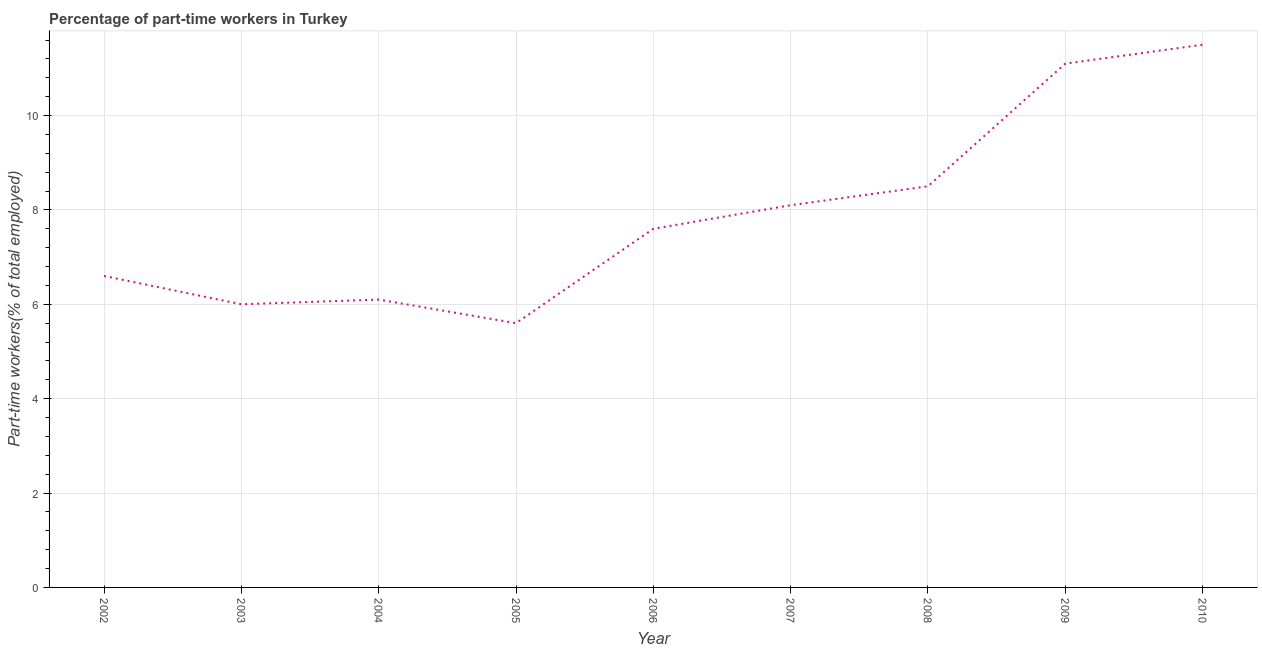What is the percentage of part-time workers in 2002?
Your response must be concise. 6.6. Across all years, what is the minimum percentage of part-time workers?
Offer a very short reply. 5.6. What is the sum of the percentage of part-time workers?
Keep it short and to the point. 71.1. What is the difference between the percentage of part-time workers in 2002 and 2006?
Provide a succinct answer. -1. What is the average percentage of part-time workers per year?
Offer a very short reply. 7.9. What is the median percentage of part-time workers?
Your answer should be compact. 7.6. In how many years, is the percentage of part-time workers greater than 3.2 %?
Your answer should be compact. 9. What is the ratio of the percentage of part-time workers in 2002 to that in 2004?
Provide a succinct answer. 1.08. Is the percentage of part-time workers in 2004 less than that in 2007?
Ensure brevity in your answer.  Yes. Is the difference between the percentage of part-time workers in 2004 and 2006 greater than the difference between any two years?
Give a very brief answer. No. What is the difference between the highest and the second highest percentage of part-time workers?
Your answer should be very brief. 0.4. What is the difference between the highest and the lowest percentage of part-time workers?
Keep it short and to the point. 5.9. In how many years, is the percentage of part-time workers greater than the average percentage of part-time workers taken over all years?
Provide a short and direct response. 4. Does the percentage of part-time workers monotonically increase over the years?
Offer a terse response. No. How many lines are there?
Provide a short and direct response. 1. Are the values on the major ticks of Y-axis written in scientific E-notation?
Provide a succinct answer. No. Does the graph contain any zero values?
Provide a succinct answer. No. Does the graph contain grids?
Your answer should be very brief. Yes. What is the title of the graph?
Keep it short and to the point. Percentage of part-time workers in Turkey. What is the label or title of the Y-axis?
Offer a very short reply. Part-time workers(% of total employed). What is the Part-time workers(% of total employed) of 2002?
Ensure brevity in your answer.  6.6. What is the Part-time workers(% of total employed) of 2004?
Make the answer very short. 6.1. What is the Part-time workers(% of total employed) of 2005?
Provide a short and direct response. 5.6. What is the Part-time workers(% of total employed) in 2006?
Your answer should be compact. 7.6. What is the Part-time workers(% of total employed) in 2007?
Provide a short and direct response. 8.1. What is the Part-time workers(% of total employed) of 2008?
Offer a terse response. 8.5. What is the Part-time workers(% of total employed) in 2009?
Your answer should be very brief. 11.1. What is the Part-time workers(% of total employed) of 2010?
Provide a succinct answer. 11.5. What is the difference between the Part-time workers(% of total employed) in 2002 and 2003?
Give a very brief answer. 0.6. What is the difference between the Part-time workers(% of total employed) in 2002 and 2004?
Provide a short and direct response. 0.5. What is the difference between the Part-time workers(% of total employed) in 2002 and 2005?
Your response must be concise. 1. What is the difference between the Part-time workers(% of total employed) in 2002 and 2007?
Give a very brief answer. -1.5. What is the difference between the Part-time workers(% of total employed) in 2002 and 2010?
Your answer should be compact. -4.9. What is the difference between the Part-time workers(% of total employed) in 2003 and 2007?
Provide a short and direct response. -2.1. What is the difference between the Part-time workers(% of total employed) in 2003 and 2008?
Your answer should be compact. -2.5. What is the difference between the Part-time workers(% of total employed) in 2003 and 2009?
Your response must be concise. -5.1. What is the difference between the Part-time workers(% of total employed) in 2003 and 2010?
Keep it short and to the point. -5.5. What is the difference between the Part-time workers(% of total employed) in 2004 and 2008?
Provide a succinct answer. -2.4. What is the difference between the Part-time workers(% of total employed) in 2004 and 2009?
Provide a short and direct response. -5. What is the difference between the Part-time workers(% of total employed) in 2004 and 2010?
Your response must be concise. -5.4. What is the difference between the Part-time workers(% of total employed) in 2005 and 2008?
Your answer should be compact. -2.9. What is the difference between the Part-time workers(% of total employed) in 2005 and 2009?
Your response must be concise. -5.5. What is the difference between the Part-time workers(% of total employed) in 2005 and 2010?
Your response must be concise. -5.9. What is the difference between the Part-time workers(% of total employed) in 2006 and 2009?
Give a very brief answer. -3.5. What is the difference between the Part-time workers(% of total employed) in 2006 and 2010?
Ensure brevity in your answer.  -3.9. What is the difference between the Part-time workers(% of total employed) in 2007 and 2009?
Make the answer very short. -3. What is the difference between the Part-time workers(% of total employed) in 2008 and 2009?
Ensure brevity in your answer.  -2.6. What is the difference between the Part-time workers(% of total employed) in 2009 and 2010?
Your answer should be compact. -0.4. What is the ratio of the Part-time workers(% of total employed) in 2002 to that in 2003?
Your response must be concise. 1.1. What is the ratio of the Part-time workers(% of total employed) in 2002 to that in 2004?
Your answer should be very brief. 1.08. What is the ratio of the Part-time workers(% of total employed) in 2002 to that in 2005?
Offer a terse response. 1.18. What is the ratio of the Part-time workers(% of total employed) in 2002 to that in 2006?
Give a very brief answer. 0.87. What is the ratio of the Part-time workers(% of total employed) in 2002 to that in 2007?
Offer a very short reply. 0.81. What is the ratio of the Part-time workers(% of total employed) in 2002 to that in 2008?
Give a very brief answer. 0.78. What is the ratio of the Part-time workers(% of total employed) in 2002 to that in 2009?
Keep it short and to the point. 0.59. What is the ratio of the Part-time workers(% of total employed) in 2002 to that in 2010?
Keep it short and to the point. 0.57. What is the ratio of the Part-time workers(% of total employed) in 2003 to that in 2005?
Ensure brevity in your answer.  1.07. What is the ratio of the Part-time workers(% of total employed) in 2003 to that in 2006?
Keep it short and to the point. 0.79. What is the ratio of the Part-time workers(% of total employed) in 2003 to that in 2007?
Keep it short and to the point. 0.74. What is the ratio of the Part-time workers(% of total employed) in 2003 to that in 2008?
Provide a short and direct response. 0.71. What is the ratio of the Part-time workers(% of total employed) in 2003 to that in 2009?
Provide a succinct answer. 0.54. What is the ratio of the Part-time workers(% of total employed) in 2003 to that in 2010?
Offer a very short reply. 0.52. What is the ratio of the Part-time workers(% of total employed) in 2004 to that in 2005?
Your response must be concise. 1.09. What is the ratio of the Part-time workers(% of total employed) in 2004 to that in 2006?
Offer a very short reply. 0.8. What is the ratio of the Part-time workers(% of total employed) in 2004 to that in 2007?
Make the answer very short. 0.75. What is the ratio of the Part-time workers(% of total employed) in 2004 to that in 2008?
Offer a very short reply. 0.72. What is the ratio of the Part-time workers(% of total employed) in 2004 to that in 2009?
Offer a very short reply. 0.55. What is the ratio of the Part-time workers(% of total employed) in 2004 to that in 2010?
Make the answer very short. 0.53. What is the ratio of the Part-time workers(% of total employed) in 2005 to that in 2006?
Ensure brevity in your answer.  0.74. What is the ratio of the Part-time workers(% of total employed) in 2005 to that in 2007?
Give a very brief answer. 0.69. What is the ratio of the Part-time workers(% of total employed) in 2005 to that in 2008?
Provide a short and direct response. 0.66. What is the ratio of the Part-time workers(% of total employed) in 2005 to that in 2009?
Offer a terse response. 0.51. What is the ratio of the Part-time workers(% of total employed) in 2005 to that in 2010?
Give a very brief answer. 0.49. What is the ratio of the Part-time workers(% of total employed) in 2006 to that in 2007?
Give a very brief answer. 0.94. What is the ratio of the Part-time workers(% of total employed) in 2006 to that in 2008?
Ensure brevity in your answer.  0.89. What is the ratio of the Part-time workers(% of total employed) in 2006 to that in 2009?
Offer a very short reply. 0.69. What is the ratio of the Part-time workers(% of total employed) in 2006 to that in 2010?
Your answer should be compact. 0.66. What is the ratio of the Part-time workers(% of total employed) in 2007 to that in 2008?
Your answer should be very brief. 0.95. What is the ratio of the Part-time workers(% of total employed) in 2007 to that in 2009?
Your response must be concise. 0.73. What is the ratio of the Part-time workers(% of total employed) in 2007 to that in 2010?
Keep it short and to the point. 0.7. What is the ratio of the Part-time workers(% of total employed) in 2008 to that in 2009?
Offer a terse response. 0.77. What is the ratio of the Part-time workers(% of total employed) in 2008 to that in 2010?
Your answer should be compact. 0.74. 